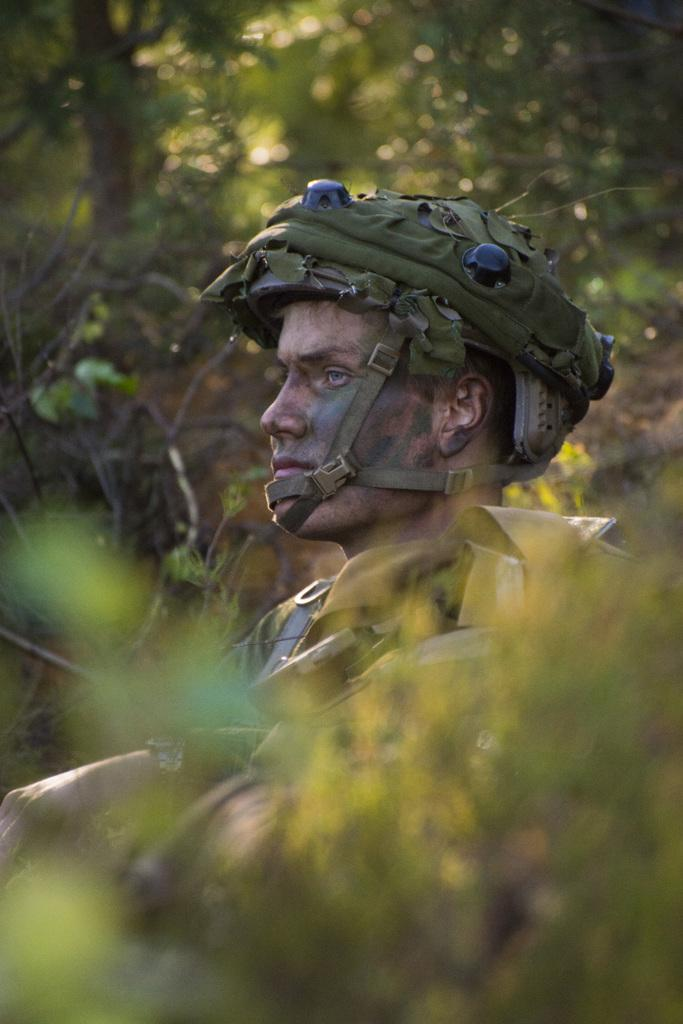Who is present in the image? There is a man in the image. What is the man wearing on his head? The man is wearing a green helmet. What type of natural environment can be seen in the image? There are trees visible in the image. How would you describe the quality of the image? The image is slightly blurry in the background. What type of glass is the man holding in the image? There is no glass present in the image; the man is wearing a green helmet. 